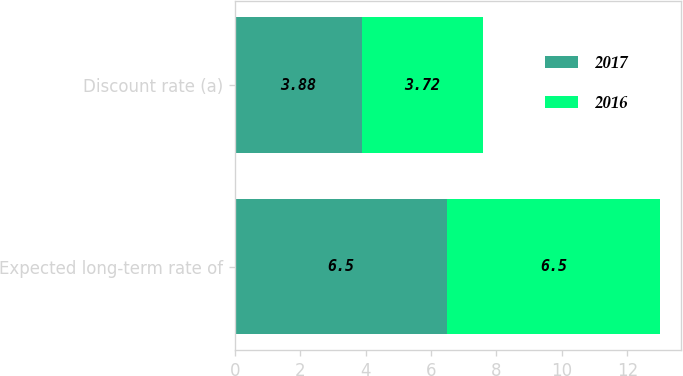Convert chart to OTSL. <chart><loc_0><loc_0><loc_500><loc_500><stacked_bar_chart><ecel><fcel>Expected long-term rate of<fcel>Discount rate (a)<nl><fcel>2017<fcel>6.5<fcel>3.88<nl><fcel>2016<fcel>6.5<fcel>3.72<nl></chart> 